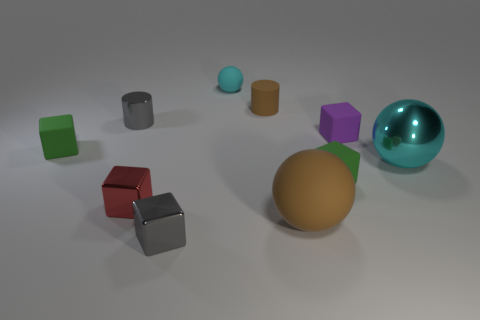Subtract all matte spheres. How many spheres are left? 1 Subtract all gray cubes. How many cubes are left? 4 Subtract 2 cubes. How many cubes are left? 3 Subtract all brown blocks. Subtract all gray cylinders. How many blocks are left? 5 Subtract all cylinders. How many objects are left? 8 Subtract 1 purple cubes. How many objects are left? 9 Subtract all small green shiny balls. Subtract all small cyan matte spheres. How many objects are left? 9 Add 4 tiny cyan things. How many tiny cyan things are left? 5 Add 7 small green shiny cylinders. How many small green shiny cylinders exist? 7 